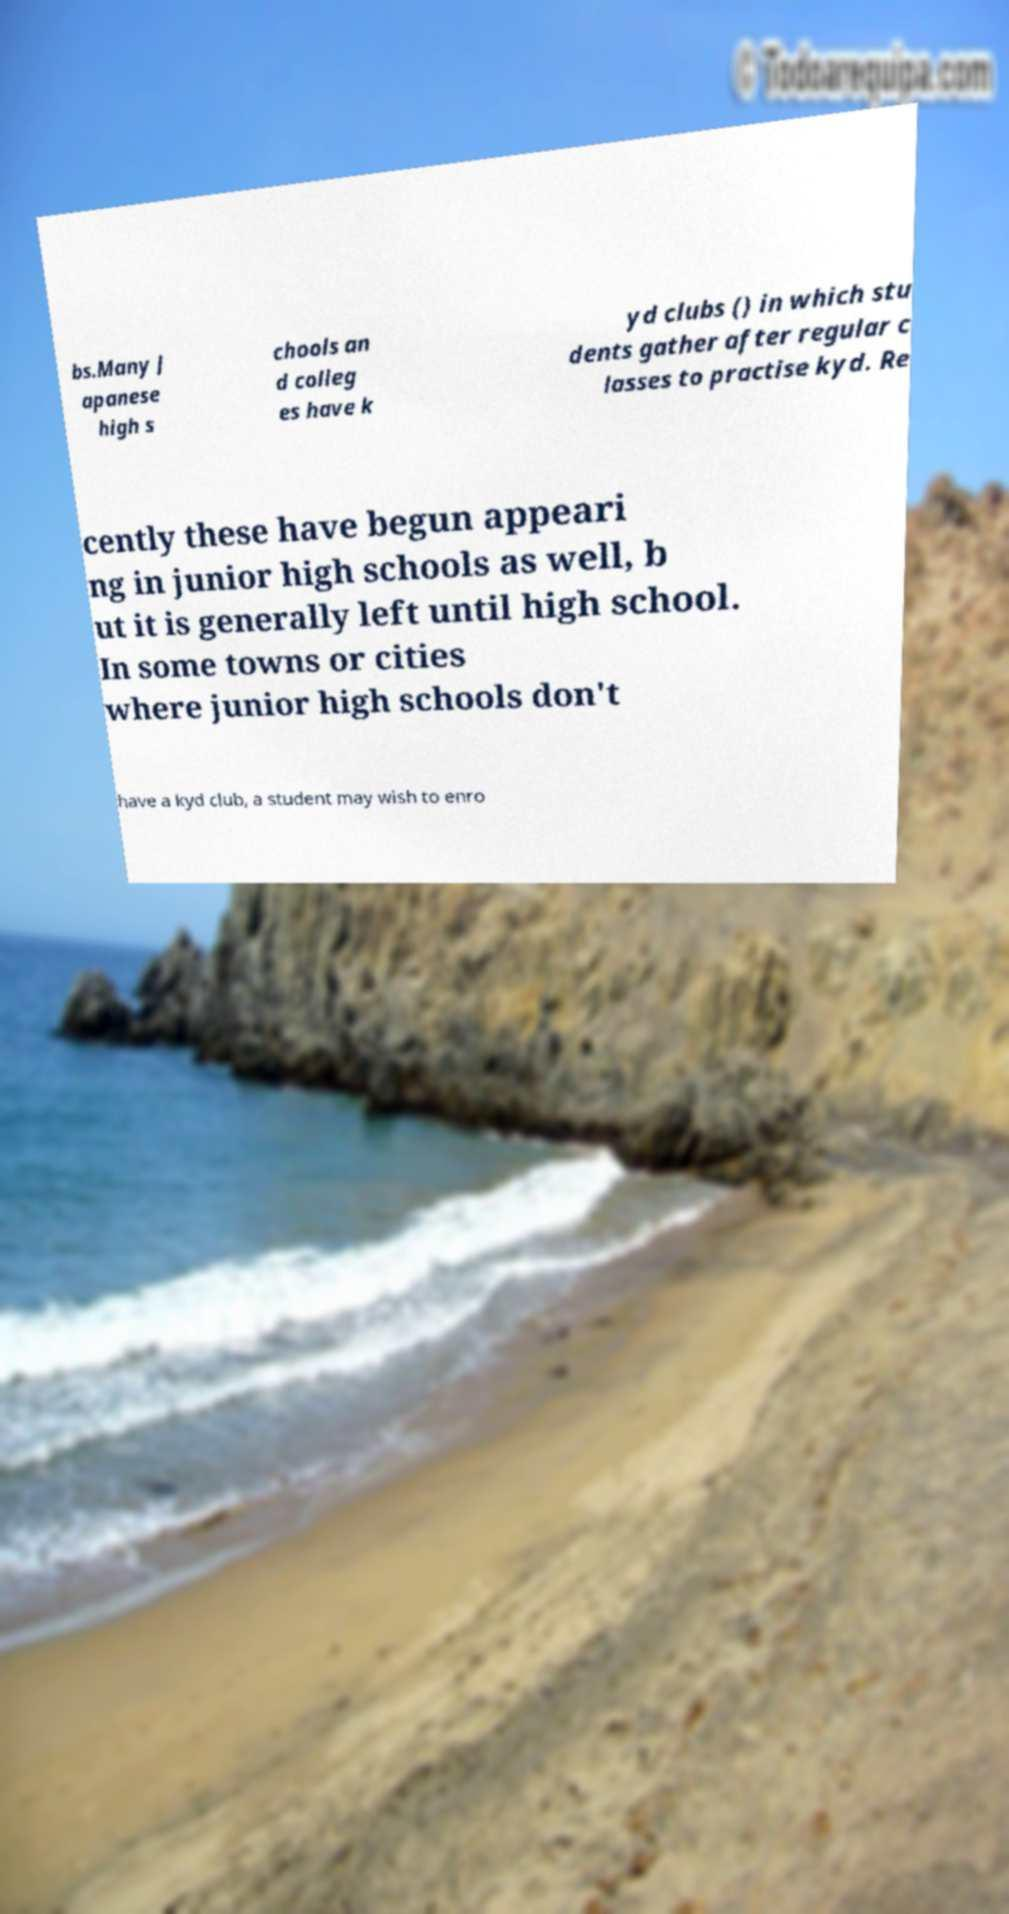Could you extract and type out the text from this image? bs.Many J apanese high s chools an d colleg es have k yd clubs () in which stu dents gather after regular c lasses to practise kyd. Re cently these have begun appeari ng in junior high schools as well, b ut it is generally left until high school. In some towns or cities where junior high schools don't have a kyd club, a student may wish to enro 